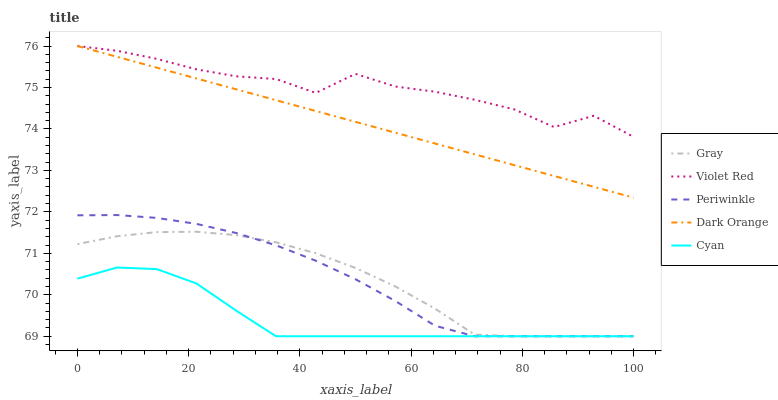Does Cyan have the minimum area under the curve?
Answer yes or no. Yes. Does Violet Red have the maximum area under the curve?
Answer yes or no. Yes. Does Periwinkle have the minimum area under the curve?
Answer yes or no. No. Does Periwinkle have the maximum area under the curve?
Answer yes or no. No. Is Dark Orange the smoothest?
Answer yes or no. Yes. Is Violet Red the roughest?
Answer yes or no. Yes. Is Periwinkle the smoothest?
Answer yes or no. No. Is Periwinkle the roughest?
Answer yes or no. No. Does Gray have the lowest value?
Answer yes or no. Yes. Does Violet Red have the lowest value?
Answer yes or no. No. Does Dark Orange have the highest value?
Answer yes or no. Yes. Does Periwinkle have the highest value?
Answer yes or no. No. Is Periwinkle less than Violet Red?
Answer yes or no. Yes. Is Violet Red greater than Periwinkle?
Answer yes or no. Yes. Does Periwinkle intersect Gray?
Answer yes or no. Yes. Is Periwinkle less than Gray?
Answer yes or no. No. Is Periwinkle greater than Gray?
Answer yes or no. No. Does Periwinkle intersect Violet Red?
Answer yes or no. No. 